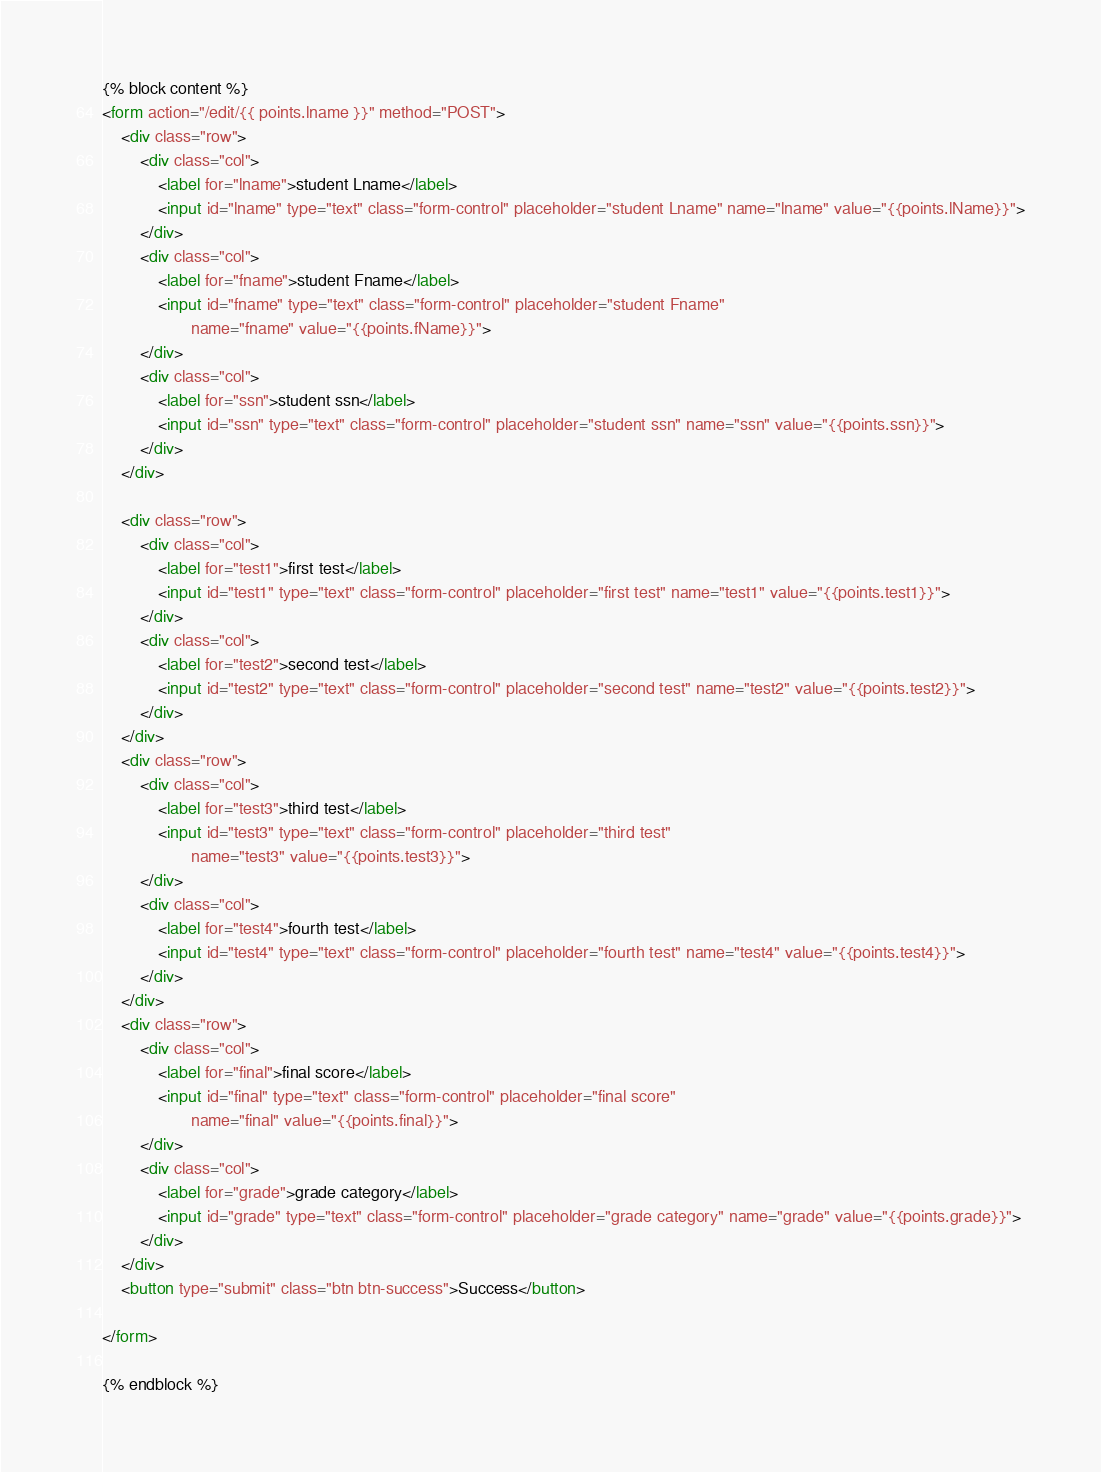<code> <loc_0><loc_0><loc_500><loc_500><_HTML_>{% block content %}
<form action="/edit/{{ points.lname }}" method="POST">
    <div class="row">
        <div class="col">
            <label for="lname">student Lname</label>
            <input id="lname" type="text" class="form-control" placeholder="student Lname" name="lname" value="{{points.lName}}">
        </div>
        <div class="col">
            <label for="fname">student Fname</label>
            <input id="fname" type="text" class="form-control" placeholder="student Fname"
                   name="fname" value="{{points.fName}}">
        </div>
        <div class="col">
            <label for="ssn">student ssn</label>
            <input id="ssn" type="text" class="form-control" placeholder="student ssn" name="ssn" value="{{points.ssn}}">
        </div>
    </div>

    <div class="row">
        <div class="col">
            <label for="test1">first test</label>
            <input id="test1" type="text" class="form-control" placeholder="first test" name="test1" value="{{points.test1}}">
        </div>
        <div class="col">
            <label for="test2">second test</label>
            <input id="test2" type="text" class="form-control" placeholder="second test" name="test2" value="{{points.test2}}">
        </div>
    </div>
    <div class="row">
        <div class="col">
            <label for="test3">third test</label>
            <input id="test3" type="text" class="form-control" placeholder="third test"
                   name="test3" value="{{points.test3}}">
        </div>
        <div class="col">
            <label for="test4">fourth test</label>
            <input id="test4" type="text" class="form-control" placeholder="fourth test" name="test4" value="{{points.test4}}">
        </div>
    </div>
    <div class="row">
        <div class="col">
            <label for="final">final score</label>
            <input id="final" type="text" class="form-control" placeholder="final score"
                   name="final" value="{{points.final}}">
        </div>
        <div class="col">
            <label for="grade">grade category</label>
            <input id="grade" type="text" class="form-control" placeholder="grade category" name="grade" value="{{points.grade}}">
        </div>
    </div>
    <button type="submit" class="btn btn-success">Success</button>

</form>

{% endblock %}</code> 